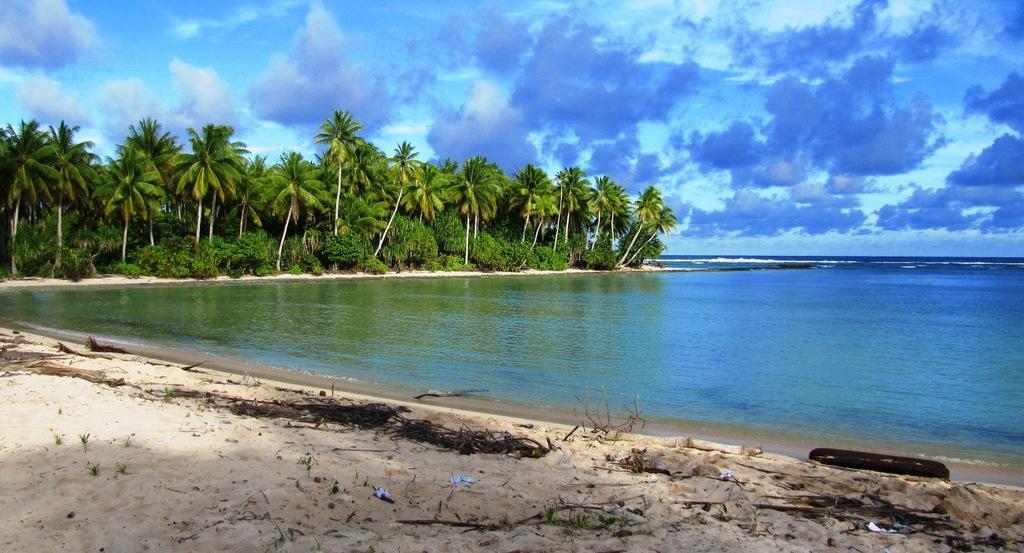Please provide a concise description of this image. In this picture I can see there is a beach and a ocean on to right side and there is sand and plants, trees and the sky is clear. 